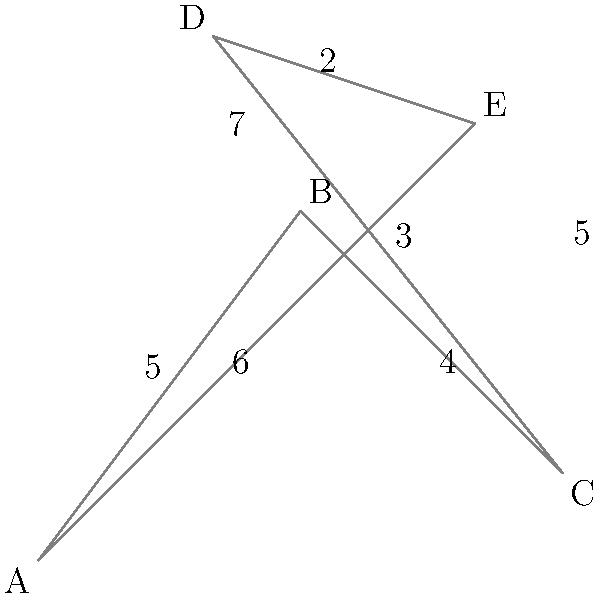As a supermarket manager, you need to determine the most efficient delivery route to visit all five stores (A, B, C, D, and E) starting and ending at store A. The distances between stores are shown on the map in kilometers. What is the total distance of the shortest possible route? To find the shortest possible route, we need to consider all possible paths that visit each store exactly once and return to store A. This is known as the Traveling Salesman Problem.

Let's analyze the possible routes:

1. A-B-C-D-E-A: $5 + 4 + 3 + 2 + 6 = 20$ km
2. A-B-C-E-D-A: $5 + 4 + 5 + 2 + 7 = 23$ km
3. A-B-D-C-E-A: $5 + 7 + 3 + 5 + 6 = 26$ km
4. A-B-D-E-C-A: $5 + 7 + 2 + 5 + 4 = 23$ km
5. A-B-E-C-D-A: $5 + 5 + 5 + 3 + 7 = 25$ km
6. A-B-E-D-C-A: $5 + 5 + 2 + 3 + 4 = 19$ km
7. A-E-B-C-D-A: $6 + 5 + 4 + 3 + 7 = 25$ km
8. A-E-B-D-C-A: $6 + 5 + 7 + 3 + 4 = 25$ km
9. A-E-C-B-D-A: $6 + 5 + 4 + 7 + 7 = 29$ km
10. A-E-C-D-B-A: $6 + 5 + 3 + 7 + 5 = 26$ km
11. A-E-D-B-C-A: $6 + 2 + 7 + 4 + 4 = 23$ km
12. A-E-D-C-B-A: $6 + 2 + 3 + 4 + 5 = 20$ km

The shortest route is A-B-E-D-C-A with a total distance of 19 km.
Answer: 19 km 